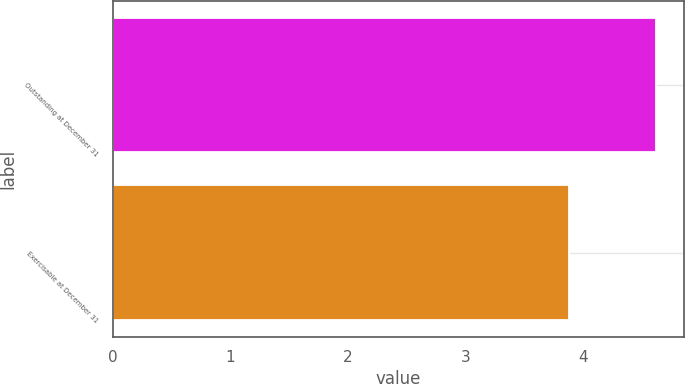<chart> <loc_0><loc_0><loc_500><loc_500><bar_chart><fcel>Outstanding at December 31<fcel>Exercisable at December 31<nl><fcel>4.62<fcel>3.88<nl></chart> 